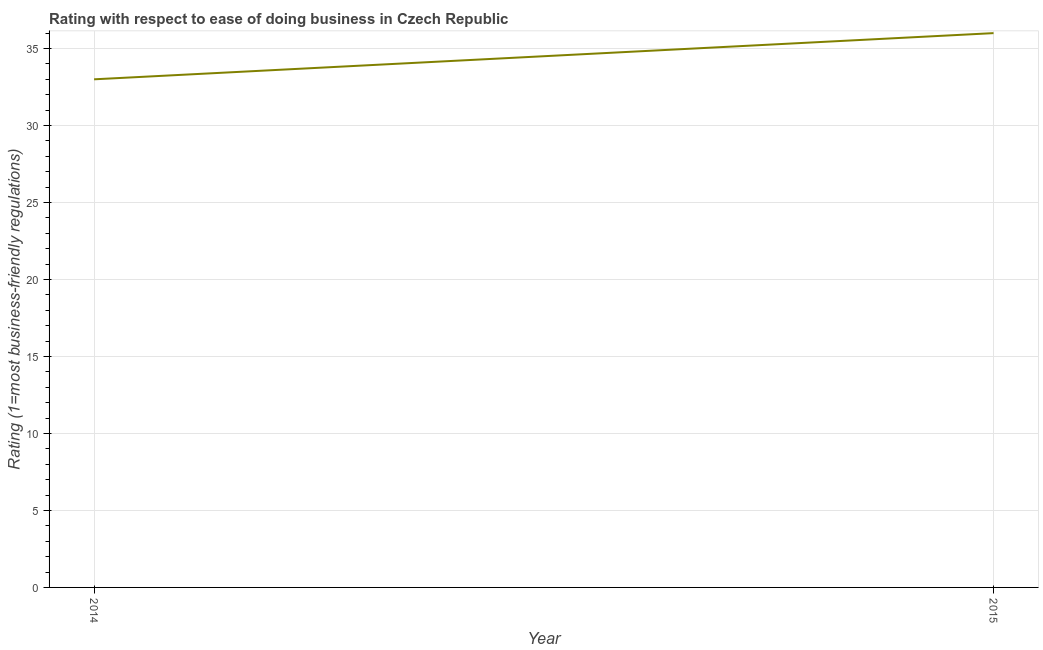What is the ease of doing business index in 2015?
Provide a short and direct response. 36. Across all years, what is the maximum ease of doing business index?
Ensure brevity in your answer.  36. Across all years, what is the minimum ease of doing business index?
Provide a succinct answer. 33. In which year was the ease of doing business index maximum?
Give a very brief answer. 2015. What is the sum of the ease of doing business index?
Keep it short and to the point. 69. What is the difference between the ease of doing business index in 2014 and 2015?
Provide a short and direct response. -3. What is the average ease of doing business index per year?
Ensure brevity in your answer.  34.5. What is the median ease of doing business index?
Provide a succinct answer. 34.5. In how many years, is the ease of doing business index greater than 3 ?
Ensure brevity in your answer.  2. What is the ratio of the ease of doing business index in 2014 to that in 2015?
Provide a succinct answer. 0.92. Does the ease of doing business index monotonically increase over the years?
Offer a very short reply. Yes. How many lines are there?
Your answer should be compact. 1. How many years are there in the graph?
Offer a very short reply. 2. Are the values on the major ticks of Y-axis written in scientific E-notation?
Keep it short and to the point. No. What is the title of the graph?
Provide a succinct answer. Rating with respect to ease of doing business in Czech Republic. What is the label or title of the X-axis?
Your answer should be very brief. Year. What is the label or title of the Y-axis?
Make the answer very short. Rating (1=most business-friendly regulations). What is the Rating (1=most business-friendly regulations) in 2015?
Your answer should be compact. 36. What is the ratio of the Rating (1=most business-friendly regulations) in 2014 to that in 2015?
Offer a terse response. 0.92. 